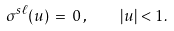Convert formula to latex. <formula><loc_0><loc_0><loc_500><loc_500>\sigma ^ { s \ell } ( u ) \, = \, 0 \, , \quad | u | < 1 .</formula> 